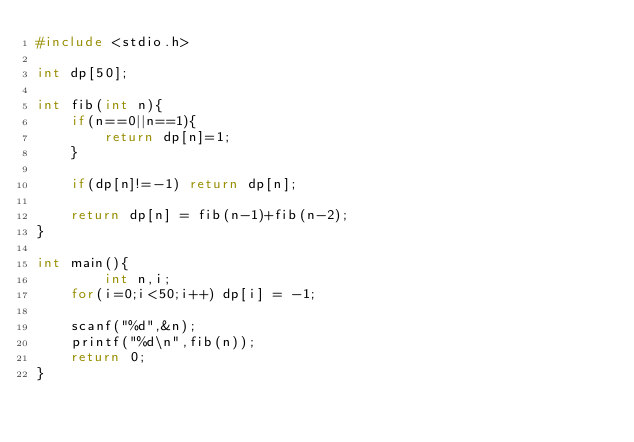Convert code to text. <code><loc_0><loc_0><loc_500><loc_500><_C_>#include <stdio.h>

int dp[50];

int fib(int n){
	if(n==0||n==1){
		return dp[n]=1;
	}
	
	if(dp[n]!=-1) return dp[n];
	
	return dp[n] = fib(n-1)+fib(n-2);
} 

int main(){
		int n,i;
	for(i=0;i<50;i++) dp[i] = -1; 

	scanf("%d",&n);
	printf("%d\n",fib(n));
	return 0;
}</code> 